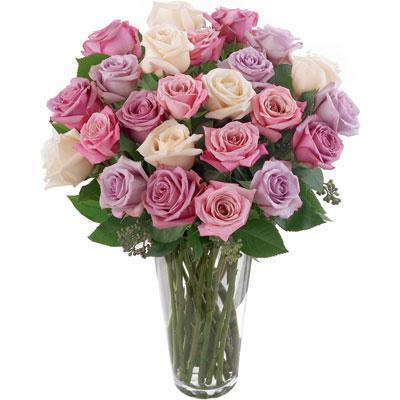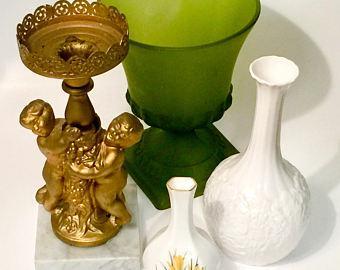The first image is the image on the left, the second image is the image on the right. Considering the images on both sides, is "There are two clear vases in one of the images." valid? Answer yes or no. No. 